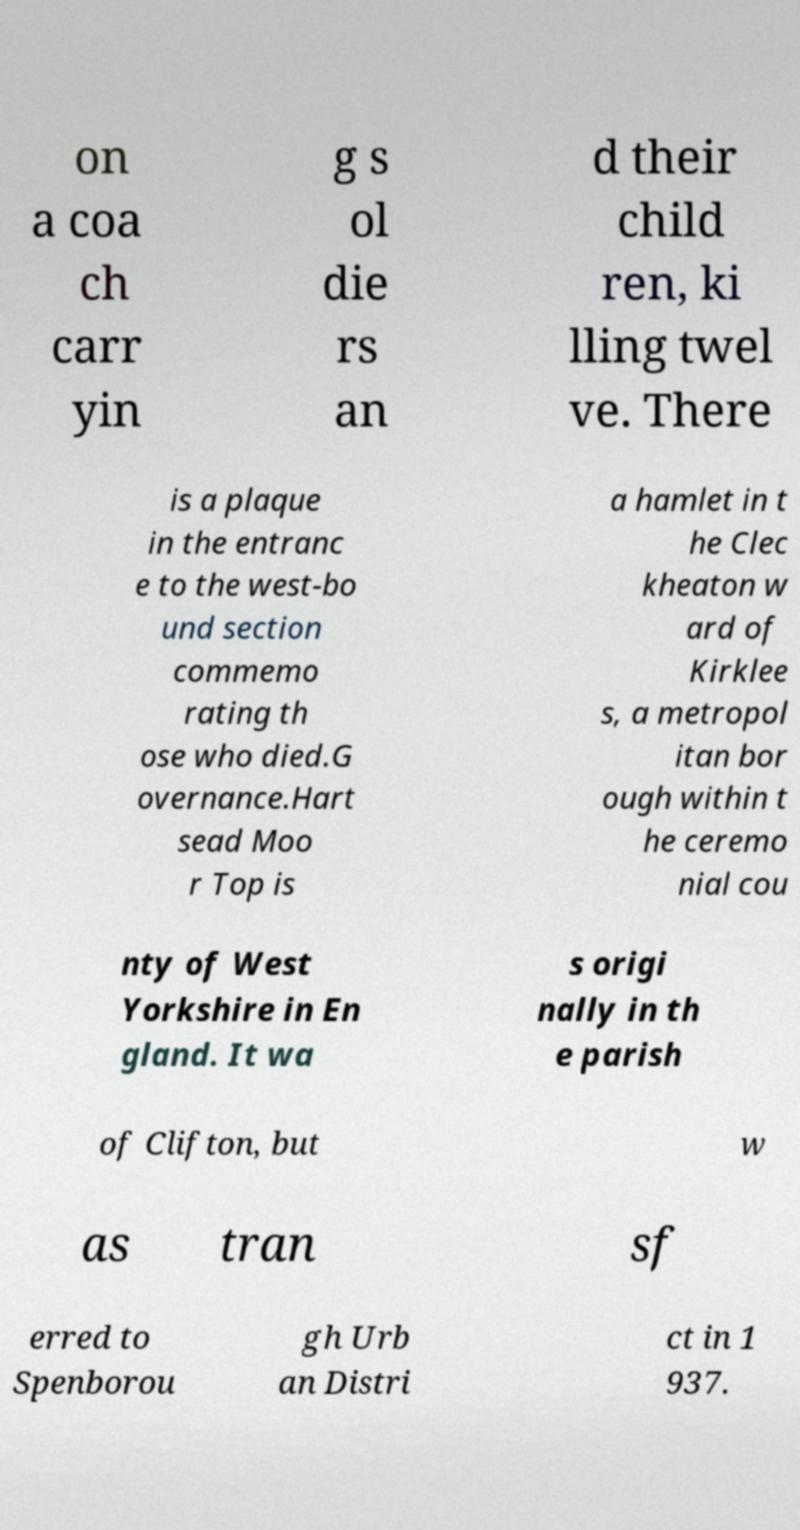Please read and relay the text visible in this image. What does it say? on a coa ch carr yin g s ol die rs an d their child ren, ki lling twel ve. There is a plaque in the entranc e to the west-bo und section commemo rating th ose who died.G overnance.Hart sead Moo r Top is a hamlet in t he Clec kheaton w ard of Kirklee s, a metropol itan bor ough within t he ceremo nial cou nty of West Yorkshire in En gland. It wa s origi nally in th e parish of Clifton, but w as tran sf erred to Spenborou gh Urb an Distri ct in 1 937. 